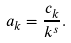Convert formula to latex. <formula><loc_0><loc_0><loc_500><loc_500>a _ { k } = \frac { c _ { k } } { k ^ { s } } .</formula> 